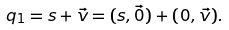<formula> <loc_0><loc_0><loc_500><loc_500>q _ { 1 } = s + { \vec { v } } = ( s , { \vec { 0 } } ) + ( 0 , { \vec { v } } ) .</formula> 